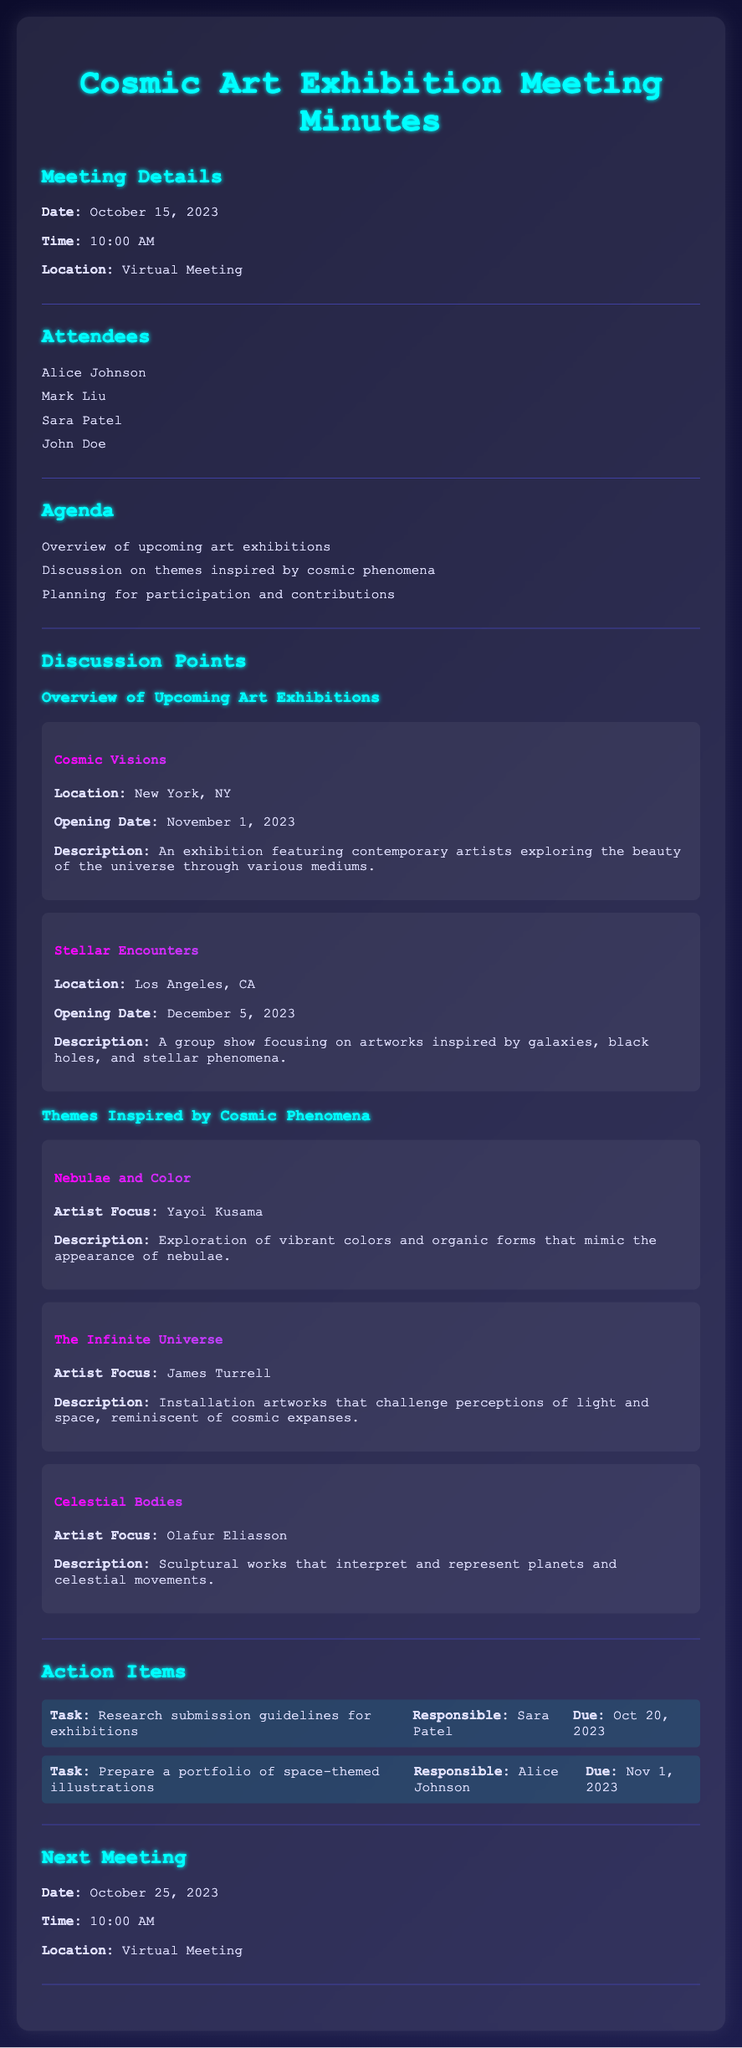What is the date of the meeting? The date of the meeting is stated in the document, which is October 15, 2023.
Answer: October 15, 2023 Who is responsible for preparing a portfolio of space-themed illustrations? The document lists action items, showing that Alice Johnson is responsible for this task.
Answer: Alice Johnson What is the opening date for the exhibition "Cosmic Visions"? The opening date is mentioned in the description of the exhibition "Cosmic Visions," which is November 1, 2023.
Answer: November 1, 2023 What theme focuses on the artist Yayoi Kusama? The document describes themes inspired by cosmic phenomena, with Yayoi Kusama's theme being "Nebulae and Color."
Answer: Nebulae and Color What will be discussed in the next meeting? The next meeting will occur on October 25, 2023, and is expected to cover updates on action items and contributions.
Answer: Updates on action items and contributions 